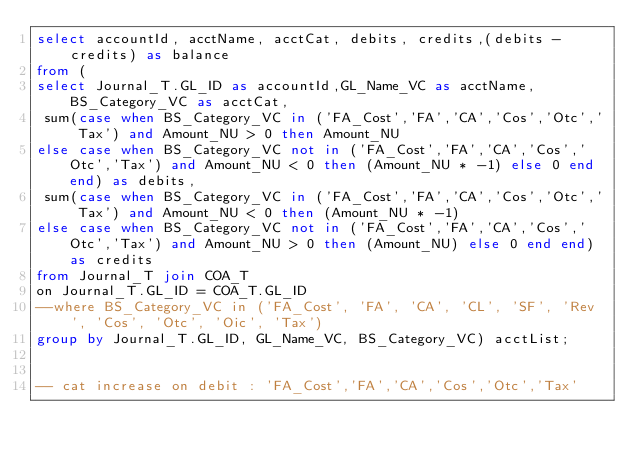Convert code to text. <code><loc_0><loc_0><loc_500><loc_500><_SQL_>select accountId, acctName, acctCat, debits, credits,(debits - credits) as balance
from (
select Journal_T.GL_ID as accountId,GL_Name_VC as acctName, BS_Category_VC as acctCat,
 sum(case when BS_Category_VC in ('FA_Cost','FA','CA','Cos','Otc','Tax') and Amount_NU > 0 then Amount_NU
else case when BS_Category_VC not in ('FA_Cost','FA','CA','Cos','Otc','Tax') and Amount_NU < 0 then (Amount_NU * -1) else 0 end end) as debits,
 sum(case when BS_Category_VC in ('FA_Cost','FA','CA','Cos','Otc','Tax') and Amount_NU < 0 then (Amount_NU * -1)
else case when BS_Category_VC not in ('FA_Cost','FA','CA','Cos','Otc','Tax') and Amount_NU > 0 then (Amount_NU) else 0 end end) as credits
from Journal_T join COA_T
on Journal_T.GL_ID = COA_T.GL_ID
--where BS_Category_VC in ('FA_Cost', 'FA', 'CA', 'CL', 'SF', 'Rev', 'Cos', 'Otc', 'Oic', 'Tax')
group by Journal_T.GL_ID, GL_Name_VC, BS_Category_VC) acctList;


-- cat increase on debit : 'FA_Cost','FA','CA','Cos','Otc','Tax'</code> 